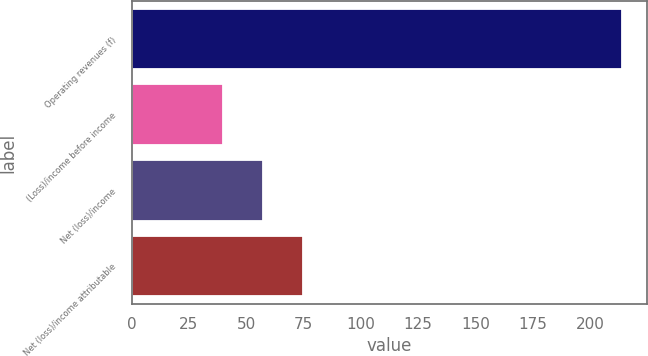<chart> <loc_0><loc_0><loc_500><loc_500><bar_chart><fcel>Operating revenues (f)<fcel>(Loss)/income before income<fcel>Net (loss)/income<fcel>Net (loss)/income attributable<nl><fcel>214<fcel>40<fcel>57.4<fcel>74.8<nl></chart> 